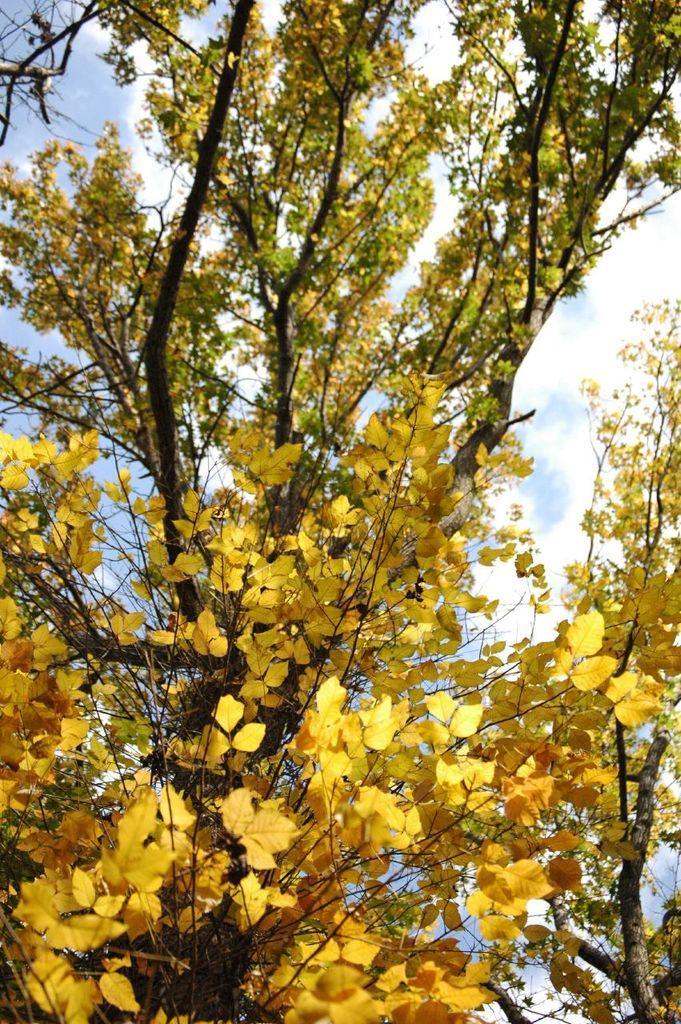How would you summarize this image in a sentence or two? In the center of the image there is a tree. In the background we can see sky and clouds. 